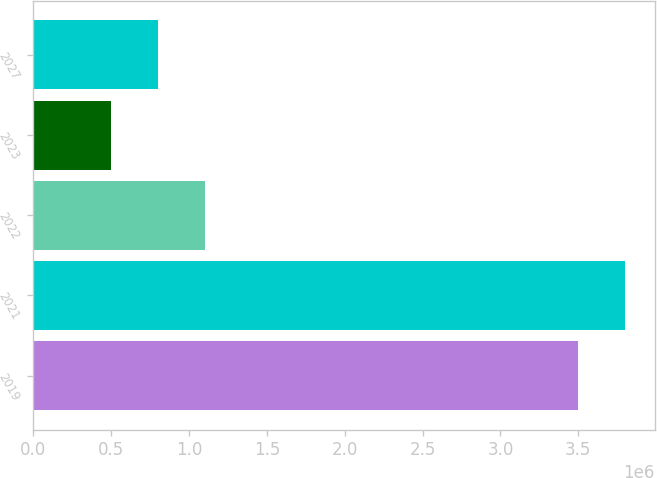<chart> <loc_0><loc_0><loc_500><loc_500><bar_chart><fcel>2019<fcel>2021<fcel>2022<fcel>2023<fcel>2027<nl><fcel>3.5e+06<fcel>3.8e+06<fcel>1.1e+06<fcel>500000<fcel>800000<nl></chart> 